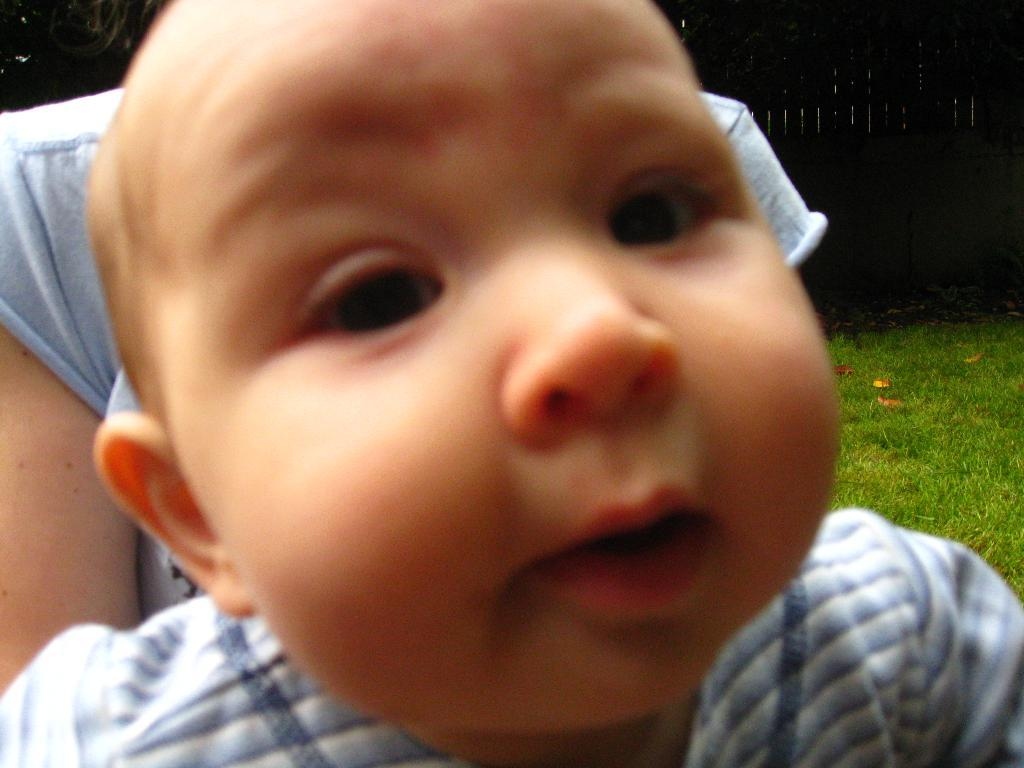What is the main subject of the picture? The main subject of the picture is a small baby. What is the baby doing in the picture? The baby is looking into the camera. Who is holding the baby in the picture? There is a woman holding the baby in the picture. What can be seen in the background of the picture? There is a grass field in the background of the picture. Can you see any ducks in the zoo in the image? There is no zoo or duck present in the image; it features a small baby being held by a woman in front of a grass field. 